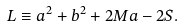<formula> <loc_0><loc_0><loc_500><loc_500>L \equiv a ^ { 2 } + b ^ { 2 } + 2 M a - 2 S .</formula> 